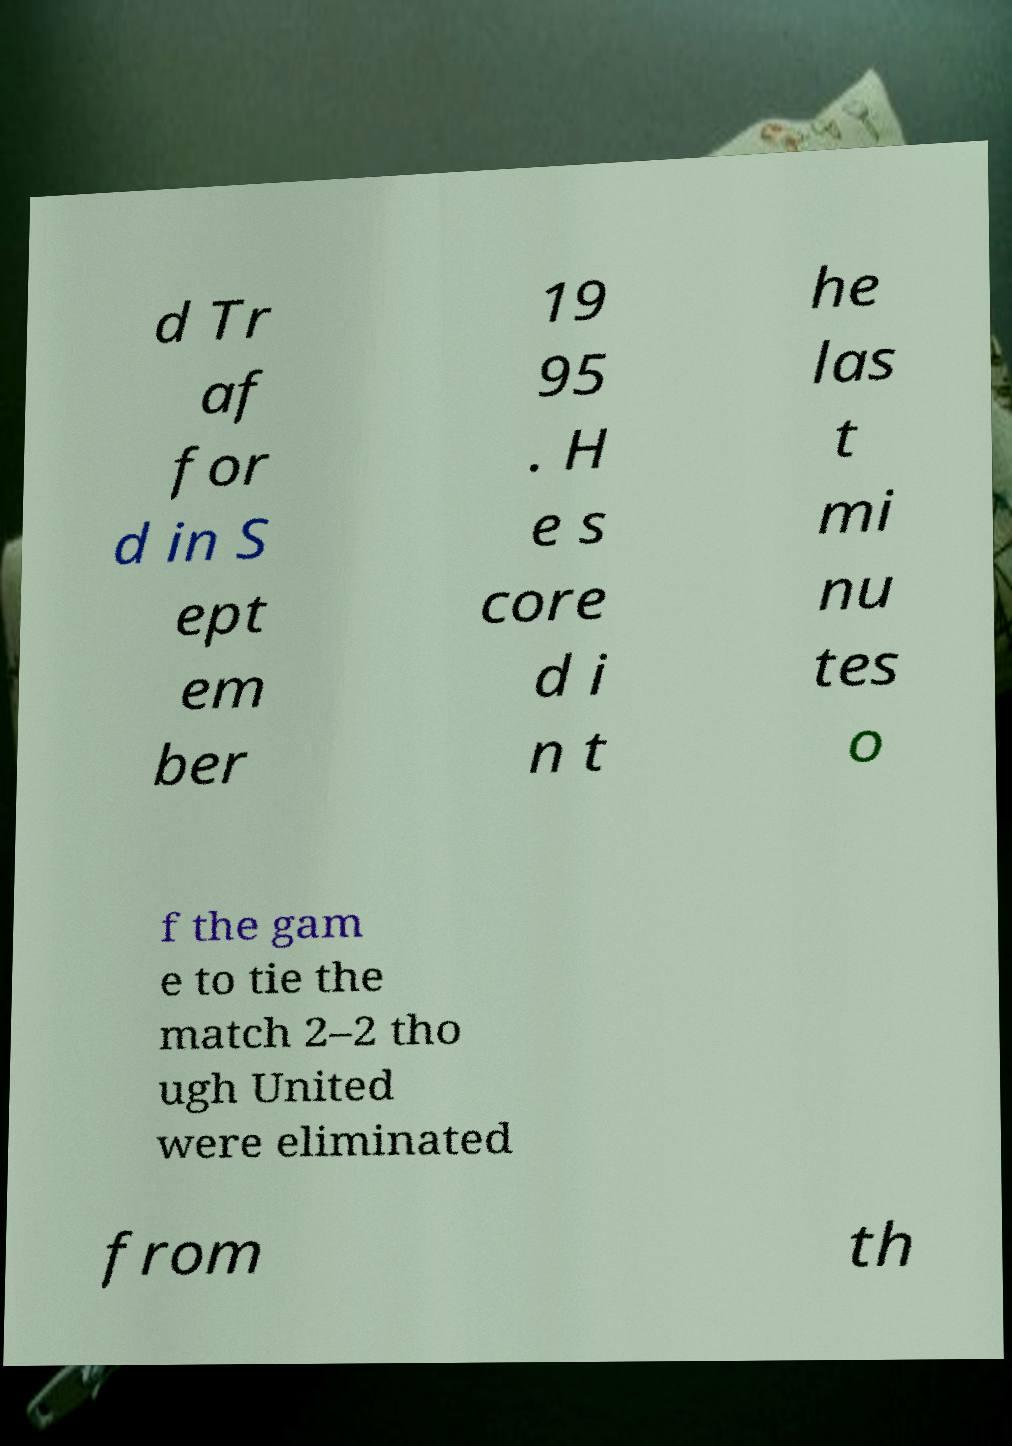Please read and relay the text visible in this image. What does it say? d Tr af for d in S ept em ber 19 95 . H e s core d i n t he las t mi nu tes o f the gam e to tie the match 2–2 tho ugh United were eliminated from th 